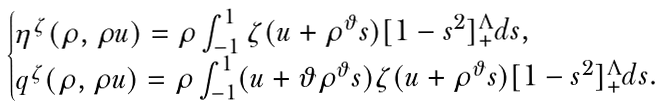<formula> <loc_0><loc_0><loc_500><loc_500>\begin{cases} \eta ^ { \zeta } ( \rho , \rho u ) = \rho \int _ { - 1 } ^ { 1 } \zeta ( u + \rho ^ { \vartheta } s ) [ 1 - s ^ { 2 } ] _ { + } ^ { \Lambda } d s , & \\ q ^ { \zeta } ( \rho , \rho u ) = \rho \int _ { - 1 } ^ { 1 } ( u + \vartheta \rho ^ { \vartheta } s ) \zeta ( u + \rho ^ { \vartheta } s ) [ 1 - s ^ { 2 } ] _ { + } ^ { \Lambda } d s . & \end{cases}</formula> 